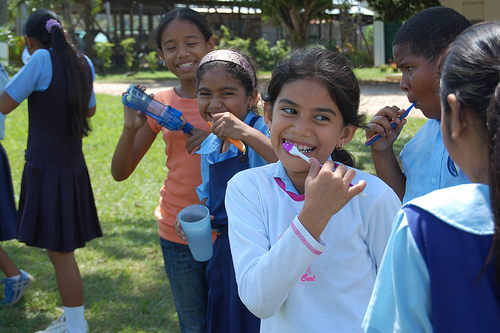Who is holding the toothbrush that looks purple? The girl in the front, wearing a white sweater with 'cool' logo and light blue jeans, is enthusiastically holding the purple toothbrush. 